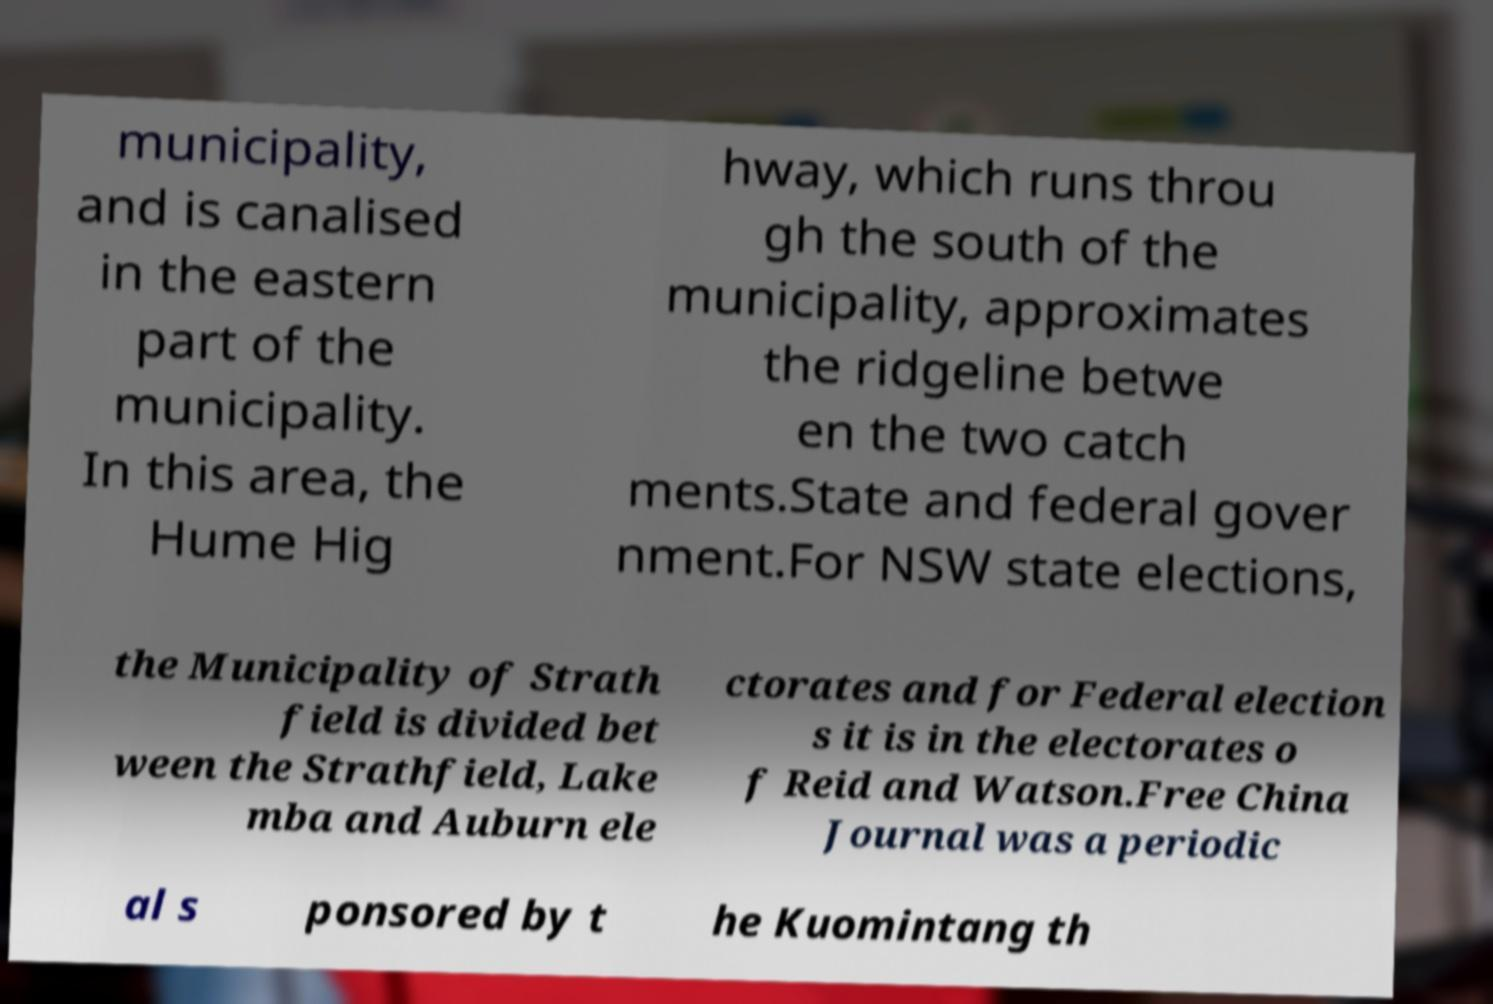Please identify and transcribe the text found in this image. municipality, and is canalised in the eastern part of the municipality. In this area, the Hume Hig hway, which runs throu gh the south of the municipality, approximates the ridgeline betwe en the two catch ments.State and federal gover nment.For NSW state elections, the Municipality of Strath field is divided bet ween the Strathfield, Lake mba and Auburn ele ctorates and for Federal election s it is in the electorates o f Reid and Watson.Free China Journal was a periodic al s ponsored by t he Kuomintang th 